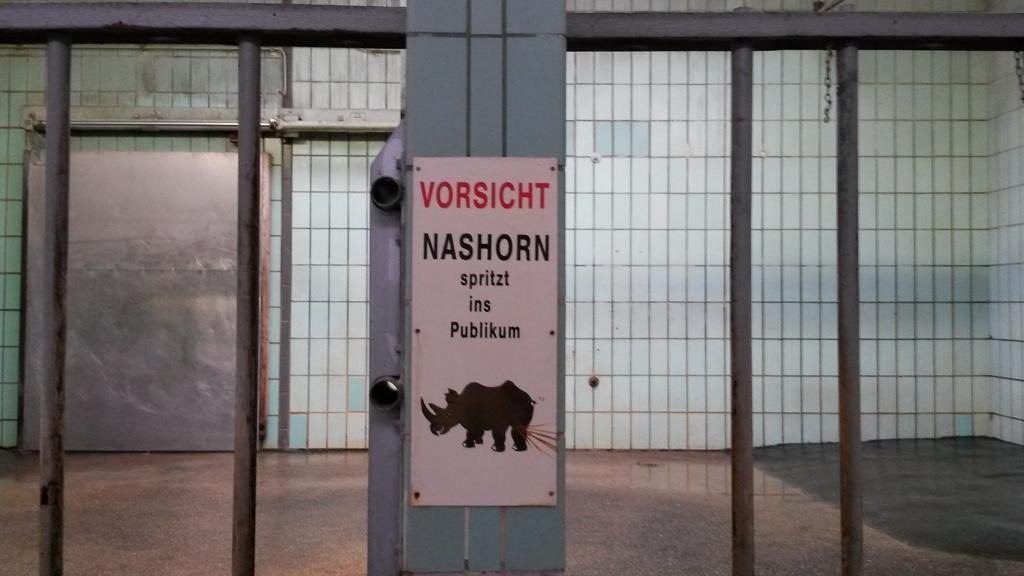What is the main object in the image? There is a sign board in the image. What else can be seen in the center of the image? There is a net in the center of the image. How many actors are present in the image? There are no actors present in the image. What type of trouble can be seen in the image? There is no trouble depicted in the image; it features a sign board and a net. 